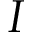<formula> <loc_0><loc_0><loc_500><loc_500>I</formula> 